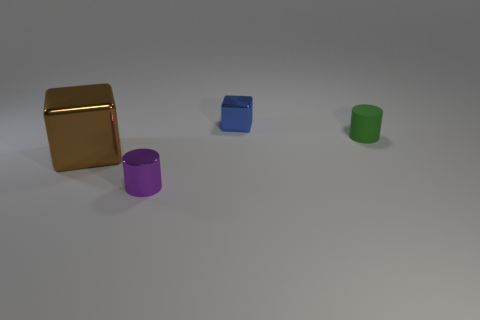Add 1 tiny brown rubber blocks. How many objects exist? 5 Subtract all purple cylinders. How many cylinders are left? 1 Subtract all cyan cubes. Subtract all green cylinders. How many cubes are left? 2 Subtract all red spheres. How many cyan blocks are left? 0 Subtract all tiny gray metal balls. Subtract all green objects. How many objects are left? 3 Add 4 brown objects. How many brown objects are left? 5 Add 3 big red things. How many big red things exist? 3 Subtract 0 cyan cylinders. How many objects are left? 4 Subtract 2 cubes. How many cubes are left? 0 